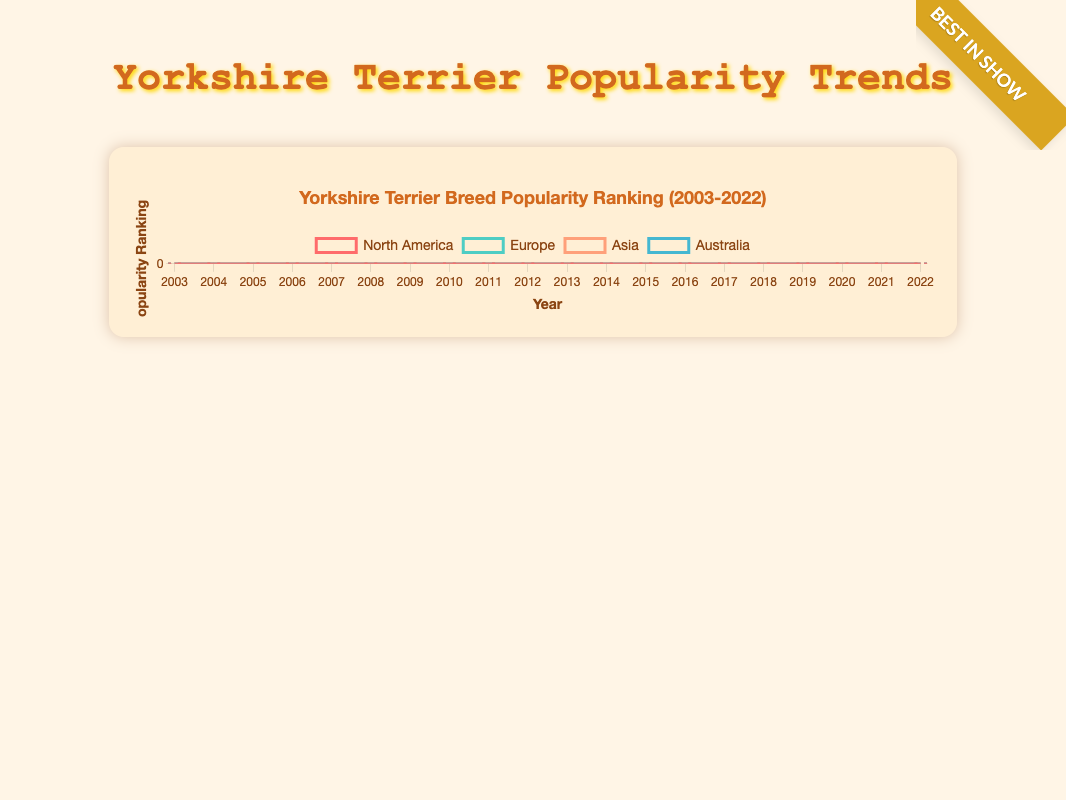Which region experienced the steepest decline in Yorkshire Terrier popularity from 2003 to 2022? To determine the steepest decline, we need to compare the differences in rankings for each region over the years. North America shows a drop from 48 to 22 (26 ranks), Europe from 35 to 16 (19 ranks), Asia from 42 to 10 (32 ranks), and Australia from 28 to 9 (19 ranks). Asia shows the steepest decline.
Answer: Asia In what year did Europe and Asia have the same popularity ranking for Yorkshire Terriers? To find the year Europe and Asia had the same rank, we look for an intersection of their lines in the figure. In the year 2008, both regions share the ranking of 30.
Answer: 2008 By how many ranks did Yorkshire Terrier popularity improve in North America and Australia from 2003 to 2022? For North America, the improvement is from 48 to 22, which is 26 ranks. For Australia, the improvement is from 28 to 9, which is 19 ranks. Summing these, the total improvement across both regions is 26 + 19 = 45 ranks.
Answer: 45 ranks Which region had the highest popularity ranking in 2022? To find the highest popularity, we look for the lowest ranking number in 2022. Asia has the rank of 10, which is the highest among the given regions.
Answer: Asia When comparing the popularity rankings of Yorkshire Terriers in 2015, which region had the lowest ranking? To identify the region with the lowest rank in 2015, we compare the ranks across regions for that year. The ranks are: North America (28), Europe (23), Asia (18), and Australia (16). Thus, Australia had the lowest rank.
Answer: Australia What is the overall trend in Yorkshire Terrier popularity in Europe from 2003 to 2022? Observing the Europe line in the figure, there is a consistent downward trend, indicating an improvement in rankings from 35 in 2003 to 16 in 2022.
Answer: Downward trend How do the end rankings of 2022 in North America and Europe compare? The ranking in North America for 2022 is 22, while in Europe it is 16. Thus, Europe has a better (lower) ranking compared to North America.
Answer: Europe has a better ranking Which region showed the most consistent increase in popularity over the years? Consistency can be observed by the smoothness of the line in the figure. Australia shows a very steady, consistent slope with few fluctuations from 28 in 2003 to 9 in 2022.
Answer: Australia What was the average ranking of Yorkshire Terriers in Asia between 2003 and 2022? We should calculate the average of all ranks for Asia from 2003 to 2022. Summing the ranks: 42 + 40 + 38 + 36 + 34 + 32 + 30 + 28 + 26 + 24 + 22 + 20 + 18 + 16 + 15 + 14 + 13 + 12 + 11 + 10 = 501. Dividing by 20 years gives 501 / 20 = 25.05.
Answer: 25.05 At what point did Yorkshire Terriers see the most significant year-over-year improvement in North America? We observe the steepest single-year drop in the figure for North America. The biggest improvement in one year is from 2020 (20) to 2021 (21), though slight, it's noticeable in comparison to other years with smoother transitions.
Answer: 2020-2021 